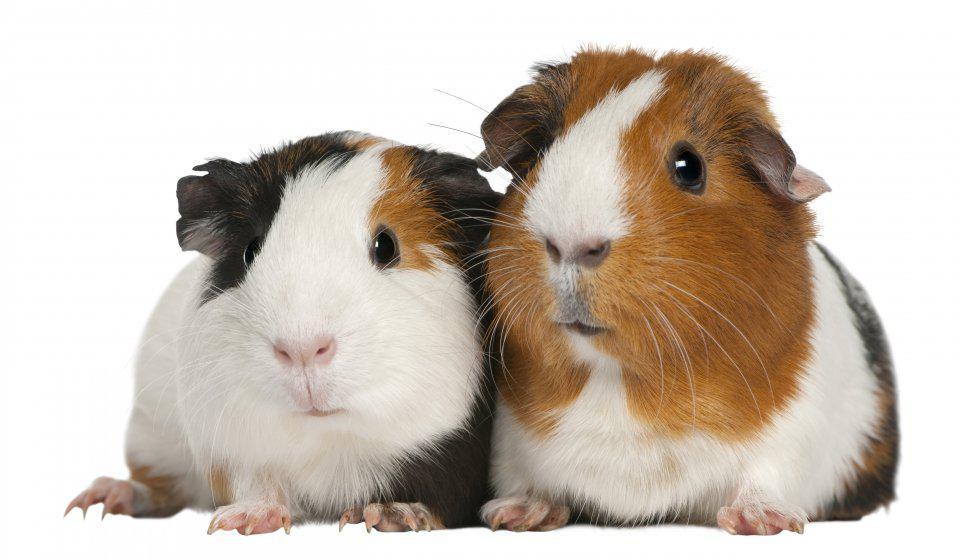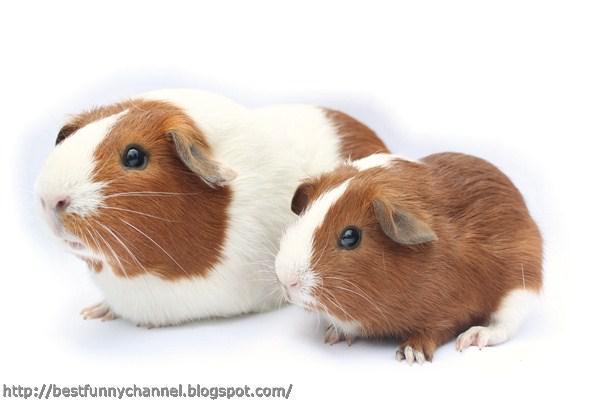The first image is the image on the left, the second image is the image on the right. Examine the images to the left and right. Is the description "Both images have two guinea pigs in them." accurate? Answer yes or no. Yes. The first image is the image on the left, the second image is the image on the right. Examine the images to the left and right. Is the description "Each image contains one pair of side-by-side guinea pigs and includes at least one guinea pig that is not solid colored." accurate? Answer yes or no. Yes. 